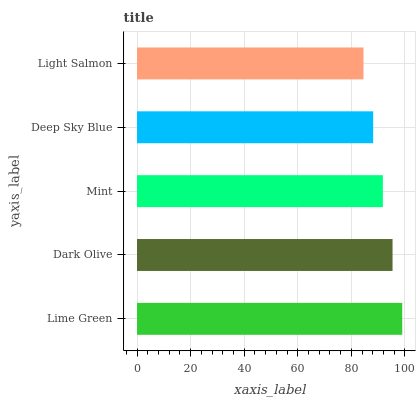Is Light Salmon the minimum?
Answer yes or no. Yes. Is Lime Green the maximum?
Answer yes or no. Yes. Is Dark Olive the minimum?
Answer yes or no. No. Is Dark Olive the maximum?
Answer yes or no. No. Is Lime Green greater than Dark Olive?
Answer yes or no. Yes. Is Dark Olive less than Lime Green?
Answer yes or no. Yes. Is Dark Olive greater than Lime Green?
Answer yes or no. No. Is Lime Green less than Dark Olive?
Answer yes or no. No. Is Mint the high median?
Answer yes or no. Yes. Is Mint the low median?
Answer yes or no. Yes. Is Lime Green the high median?
Answer yes or no. No. Is Light Salmon the low median?
Answer yes or no. No. 